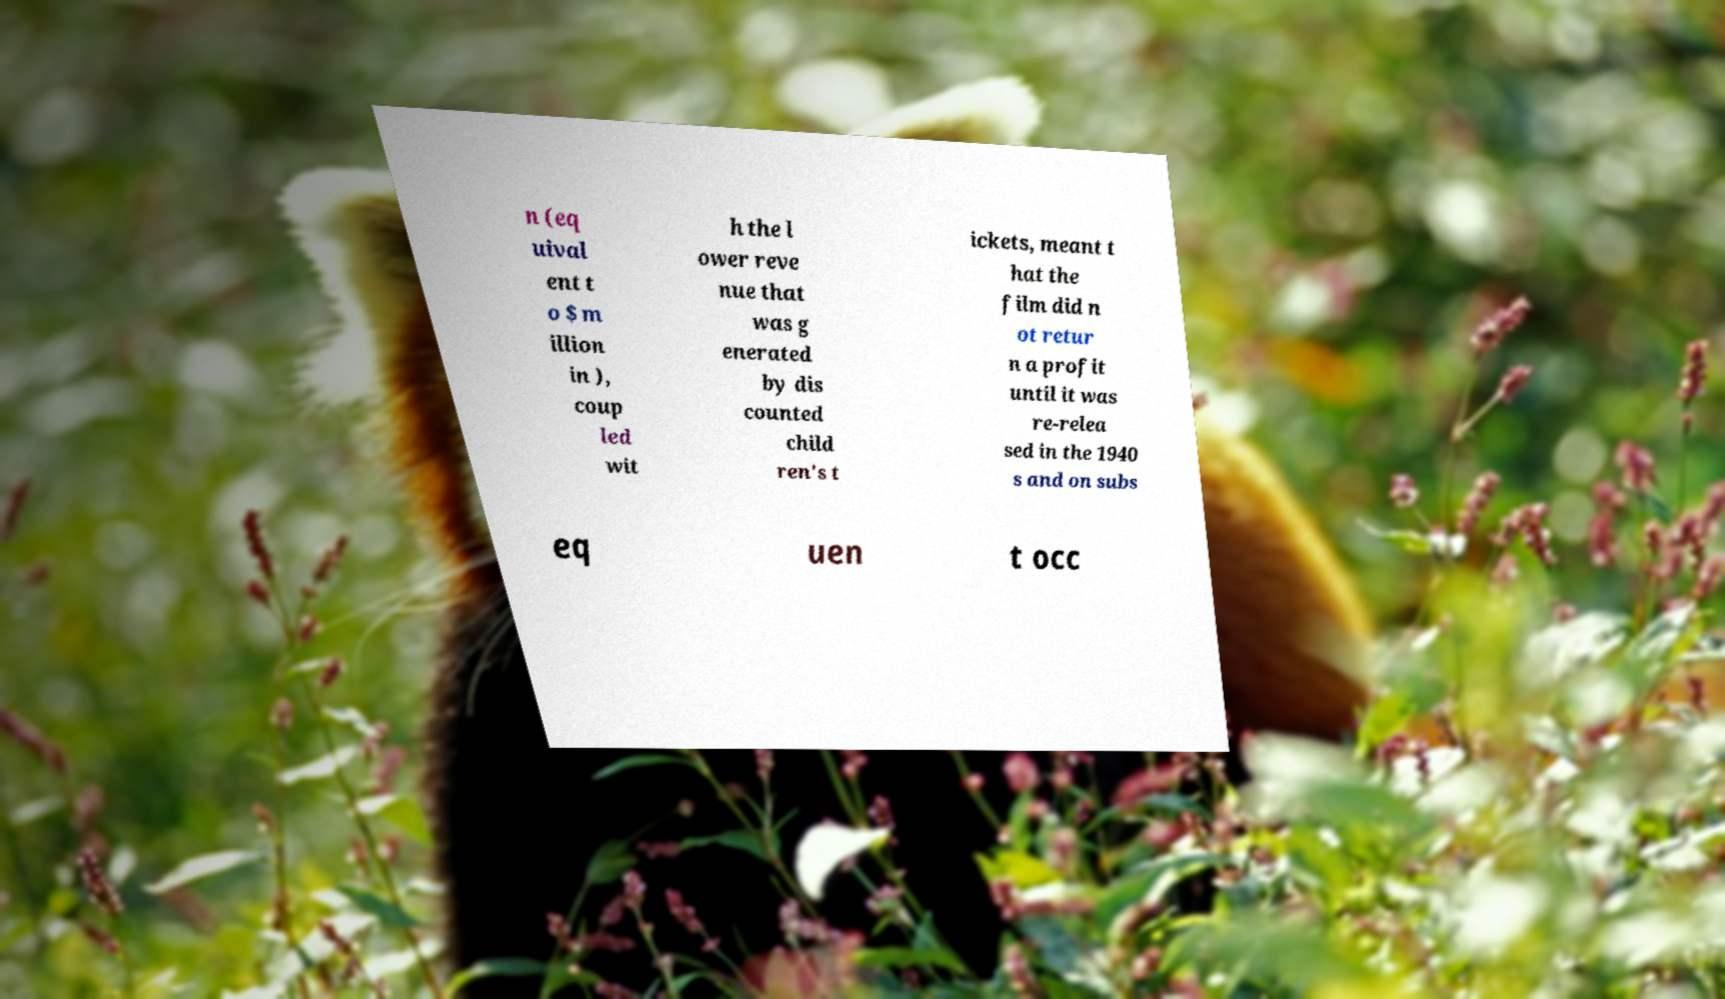Could you extract and type out the text from this image? n (eq uival ent t o $ m illion in ), coup led wit h the l ower reve nue that was g enerated by dis counted child ren's t ickets, meant t hat the film did n ot retur n a profit until it was re-relea sed in the 1940 s and on subs eq uen t occ 